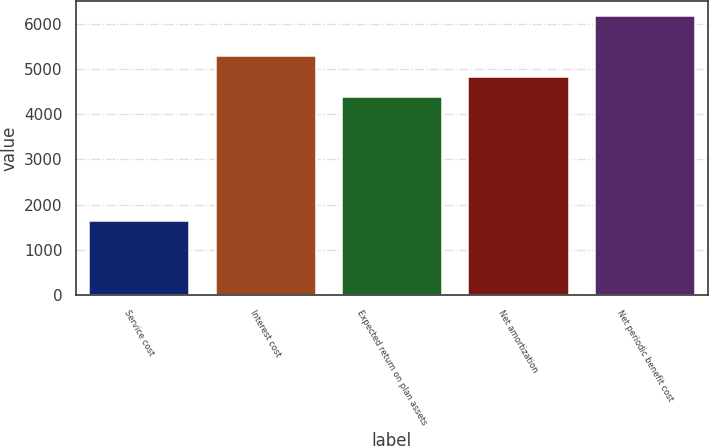<chart> <loc_0><loc_0><loc_500><loc_500><bar_chart><fcel>Service cost<fcel>Interest cost<fcel>Expected return on plan assets<fcel>Net amortization<fcel>Net periodic benefit cost<nl><fcel>1665<fcel>5302<fcel>4396<fcel>4849<fcel>6195<nl></chart> 